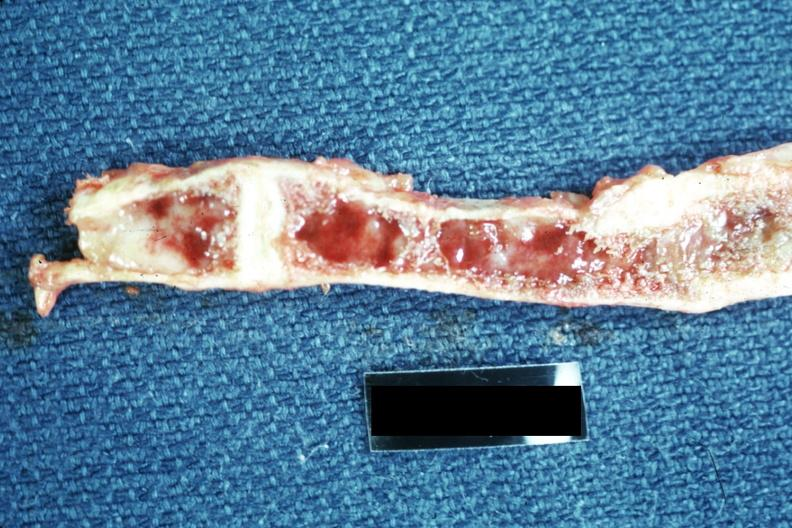what does this image show?
Answer the question using a single word or phrase. Not a good exposure 